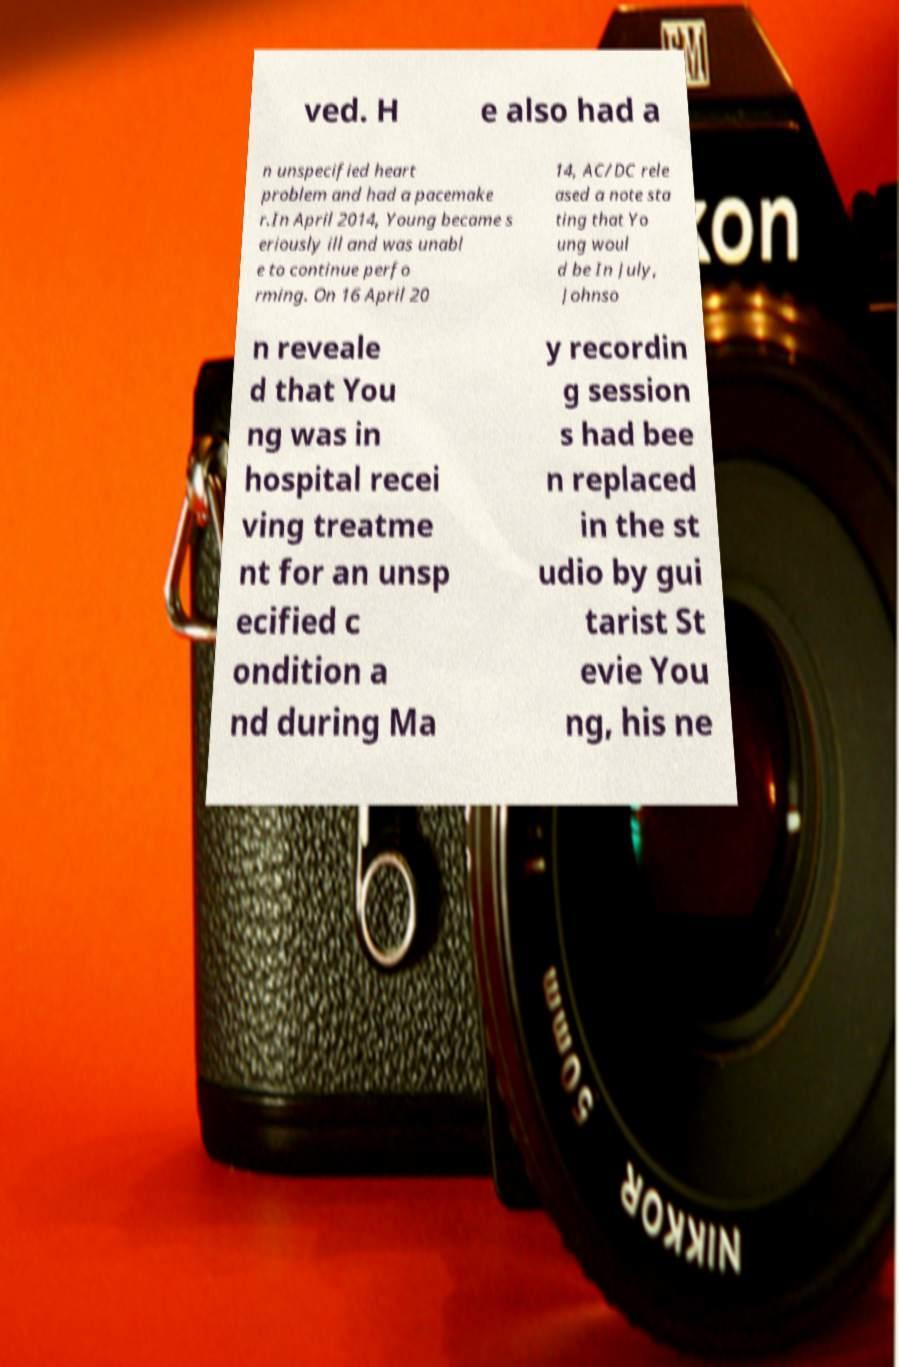There's text embedded in this image that I need extracted. Can you transcribe it verbatim? ved. H e also had a n unspecified heart problem and had a pacemake r.In April 2014, Young became s eriously ill and was unabl e to continue perfo rming. On 16 April 20 14, AC/DC rele ased a note sta ting that Yo ung woul d be In July, Johnso n reveale d that You ng was in hospital recei ving treatme nt for an unsp ecified c ondition a nd during Ma y recordin g session s had bee n replaced in the st udio by gui tarist St evie You ng, his ne 